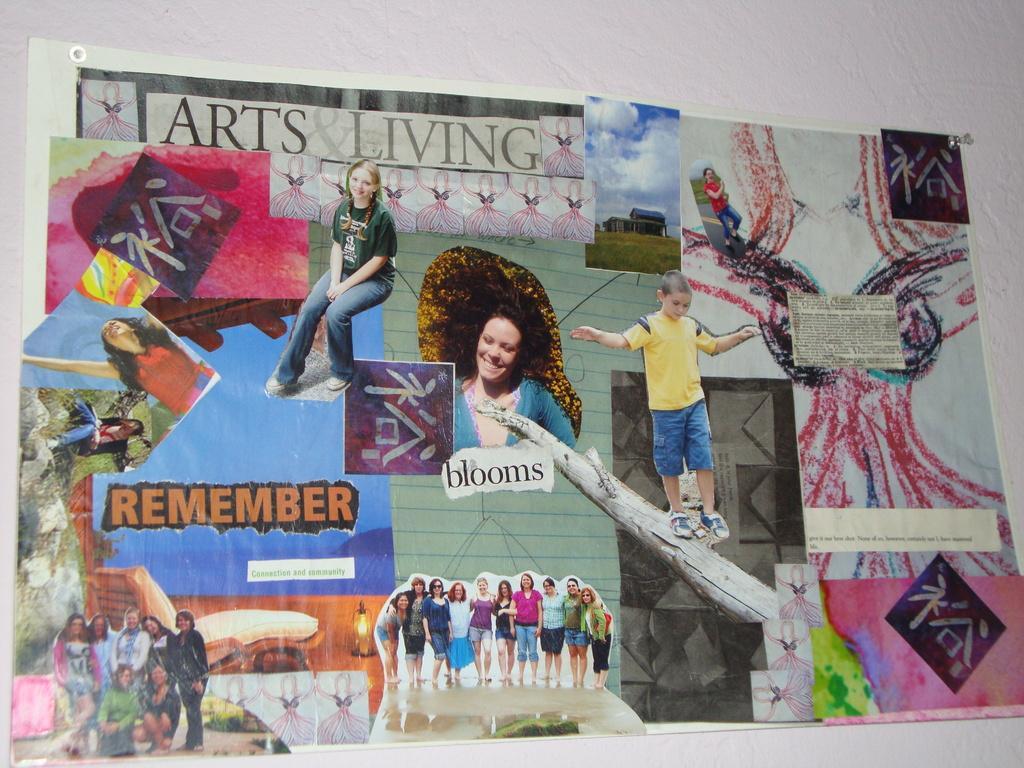Please provide a concise description of this image. In this image we can see a paper on which some pictures and text was pasted. 